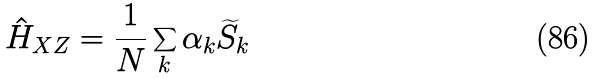Convert formula to latex. <formula><loc_0><loc_0><loc_500><loc_500>\hat { H } _ { X Z } = \frac { 1 } { N } \sum _ { k } \alpha _ { k } \widetilde { S } _ { k }</formula> 